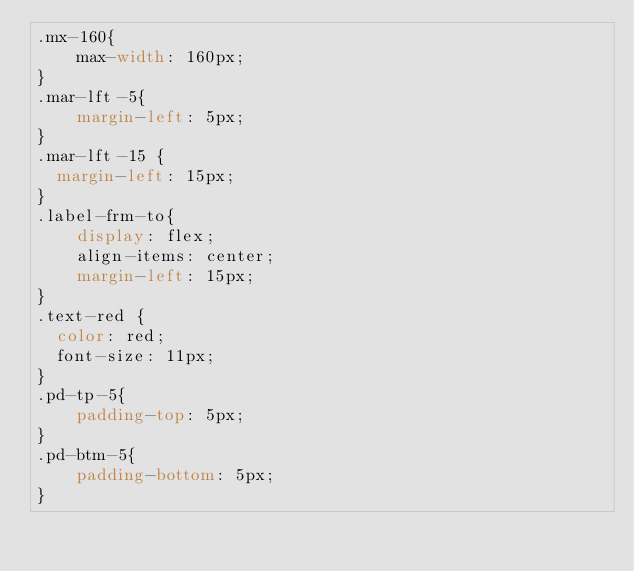<code> <loc_0><loc_0><loc_500><loc_500><_CSS_>.mx-160{
    max-width: 160px;
}
.mar-lft-5{
    margin-left: 5px;
}
.mar-lft-15 {
  margin-left: 15px;
}
.label-frm-to{
    display: flex;
    align-items: center;
    margin-left: 15px;
}
.text-red {
  color: red;
  font-size: 11px;
}
.pd-tp-5{
    padding-top: 5px;
}
.pd-btm-5{
    padding-bottom: 5px;
}
</code> 